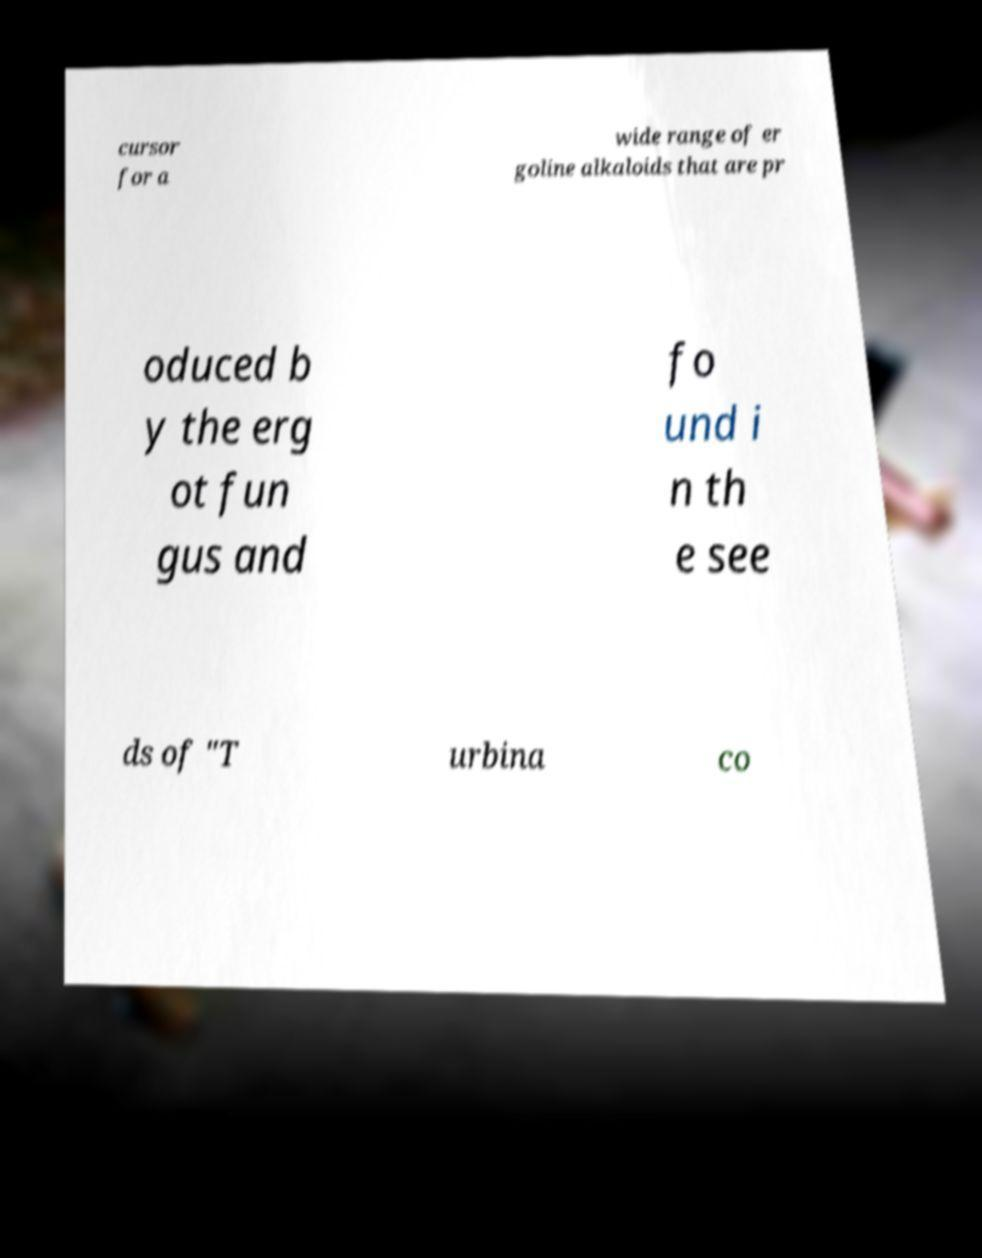Could you extract and type out the text from this image? cursor for a wide range of er goline alkaloids that are pr oduced b y the erg ot fun gus and fo und i n th e see ds of "T urbina co 